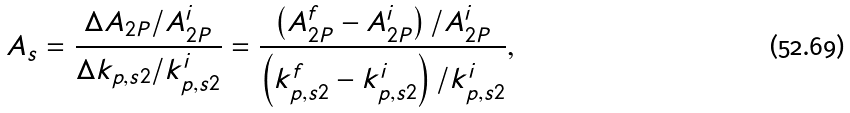<formula> <loc_0><loc_0><loc_500><loc_500>A _ { s } = \frac { \Delta A _ { 2 P } / A _ { 2 P } ^ { i } } { \Delta k _ { p , s 2 } / k _ { p , s 2 } ^ { i } } = \frac { \left ( A _ { 2 P } ^ { f } - A _ { 2 P } ^ { i } \right ) / A _ { 2 P } ^ { i } } { \left ( k _ { p , s 2 } ^ { f } - k _ { p , s 2 } ^ { i } \right ) / k _ { p , s 2 } ^ { i } } ,</formula> 